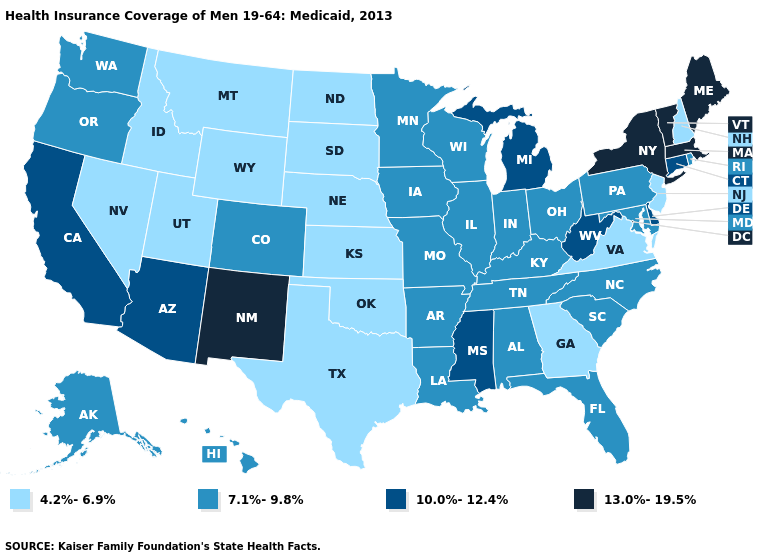What is the lowest value in the MidWest?
Short answer required. 4.2%-6.9%. Does New Mexico have the lowest value in the West?
Write a very short answer. No. Name the states that have a value in the range 10.0%-12.4%?
Keep it brief. Arizona, California, Connecticut, Delaware, Michigan, Mississippi, West Virginia. Which states hav the highest value in the South?
Short answer required. Delaware, Mississippi, West Virginia. Name the states that have a value in the range 10.0%-12.4%?
Be succinct. Arizona, California, Connecticut, Delaware, Michigan, Mississippi, West Virginia. What is the lowest value in states that border New Jersey?
Keep it brief. 7.1%-9.8%. How many symbols are there in the legend?
Keep it brief. 4. Does New Jersey have the lowest value in the Northeast?
Give a very brief answer. Yes. What is the value of Idaho?
Concise answer only. 4.2%-6.9%. What is the value of Kentucky?
Be succinct. 7.1%-9.8%. Does the first symbol in the legend represent the smallest category?
Give a very brief answer. Yes. Name the states that have a value in the range 7.1%-9.8%?
Concise answer only. Alabama, Alaska, Arkansas, Colorado, Florida, Hawaii, Illinois, Indiana, Iowa, Kentucky, Louisiana, Maryland, Minnesota, Missouri, North Carolina, Ohio, Oregon, Pennsylvania, Rhode Island, South Carolina, Tennessee, Washington, Wisconsin. Does Louisiana have the lowest value in the USA?
Short answer required. No. What is the value of New Mexico?
Write a very short answer. 13.0%-19.5%. 